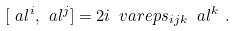Convert formula to latex. <formula><loc_0><loc_0><loc_500><loc_500>[ \ a l ^ { i } , \ a l ^ { j } ] = 2 i \, \ v a r e p s _ { i j k } \, \ a l ^ { k } \ . \label l { s u 2 }</formula> 